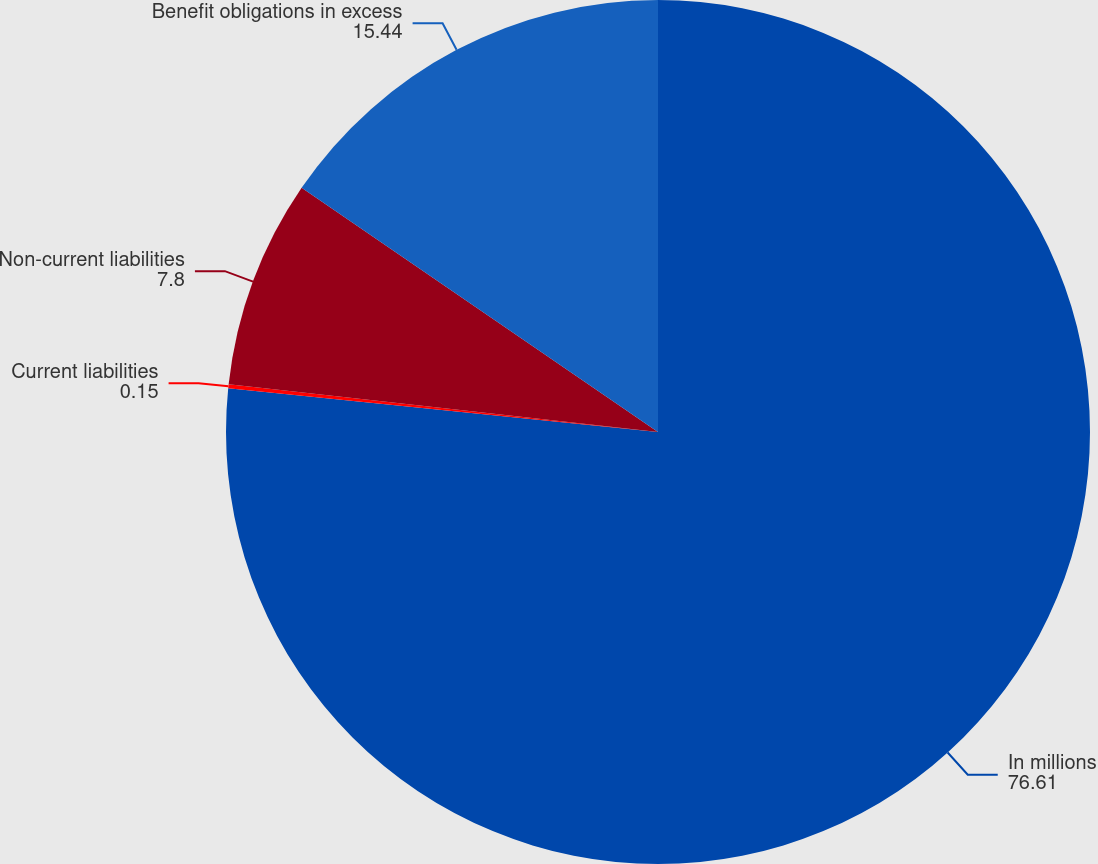Convert chart to OTSL. <chart><loc_0><loc_0><loc_500><loc_500><pie_chart><fcel>In millions<fcel>Current liabilities<fcel>Non-current liabilities<fcel>Benefit obligations in excess<nl><fcel>76.61%<fcel>0.15%<fcel>7.8%<fcel>15.44%<nl></chart> 